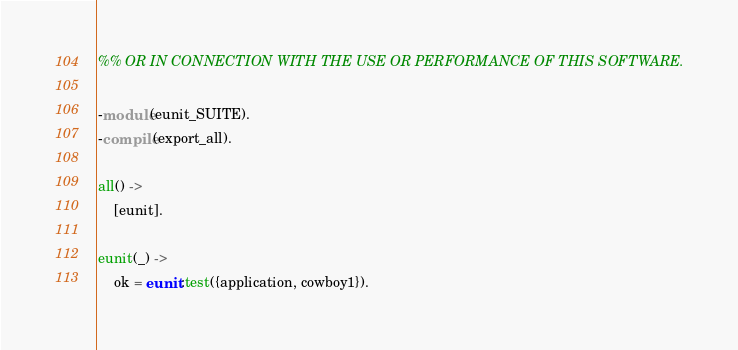Convert code to text. <code><loc_0><loc_0><loc_500><loc_500><_Erlang_>%% OR IN CONNECTION WITH THE USE OR PERFORMANCE OF THIS SOFTWARE.

-module(eunit_SUITE).
-compile(export_all).

all() ->
	[eunit].

eunit(_) ->
	ok = eunit:test({application, cowboy1}).
</code> 